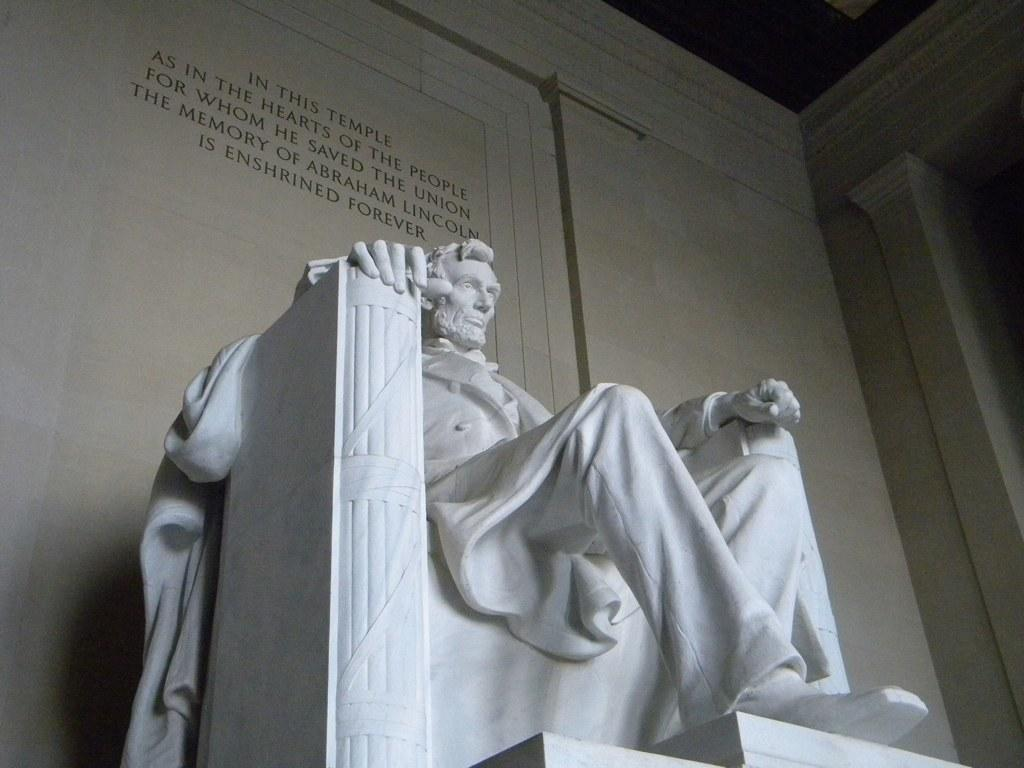What is the main subject in the foreground of the image? There is a sculpture in the foreground of the image. What can be seen behind the sculpture? There is a wall behind the sculpture. Are there any additional details on the wall? Yes, there is text on the wall. How many rings can be seen hanging from the sculpture in the image? There are no rings visible on the sculpture in the image. 